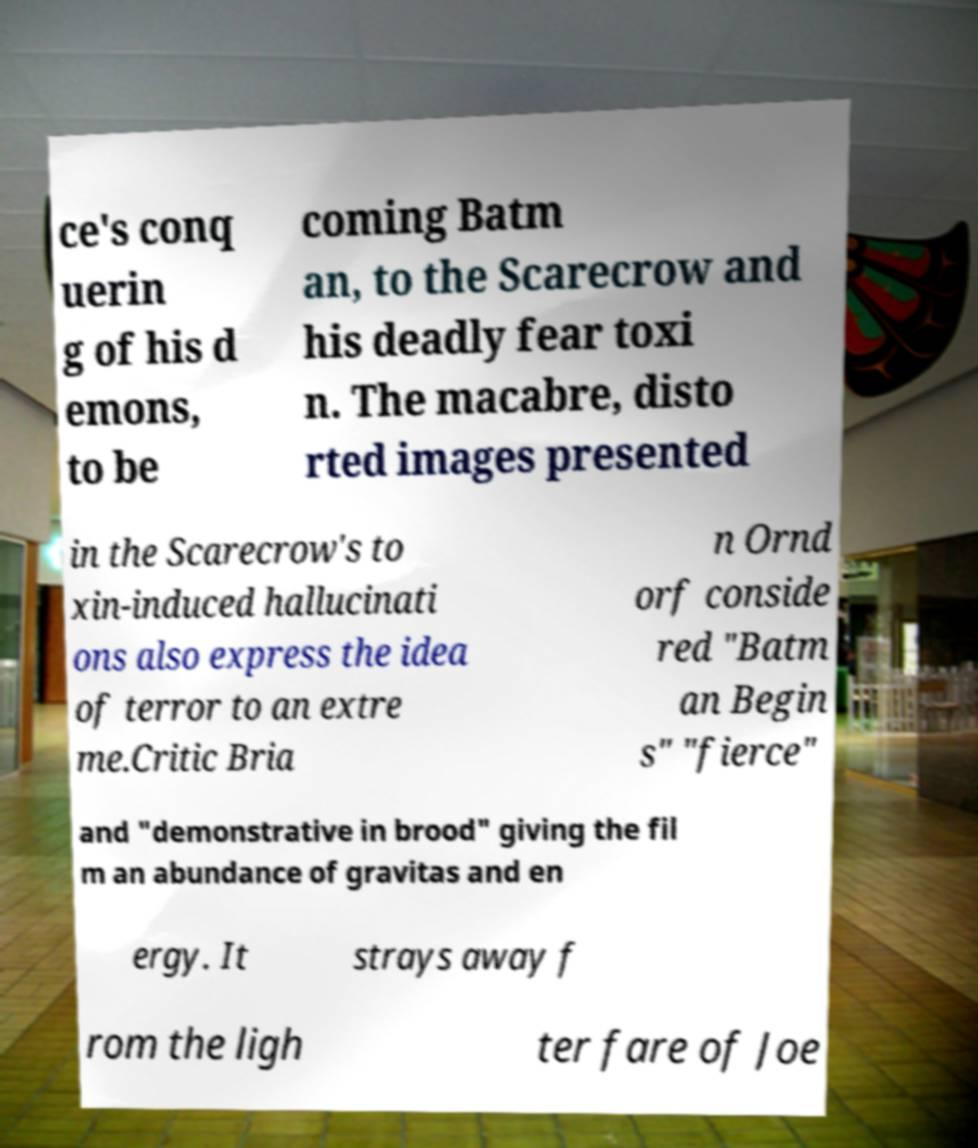What messages or text are displayed in this image? I need them in a readable, typed format. ce's conq uerin g of his d emons, to be coming Batm an, to the Scarecrow and his deadly fear toxi n. The macabre, disto rted images presented in the Scarecrow's to xin-induced hallucinati ons also express the idea of terror to an extre me.Critic Bria n Ornd orf conside red "Batm an Begin s" "fierce" and "demonstrative in brood" giving the fil m an abundance of gravitas and en ergy. It strays away f rom the ligh ter fare of Joe 